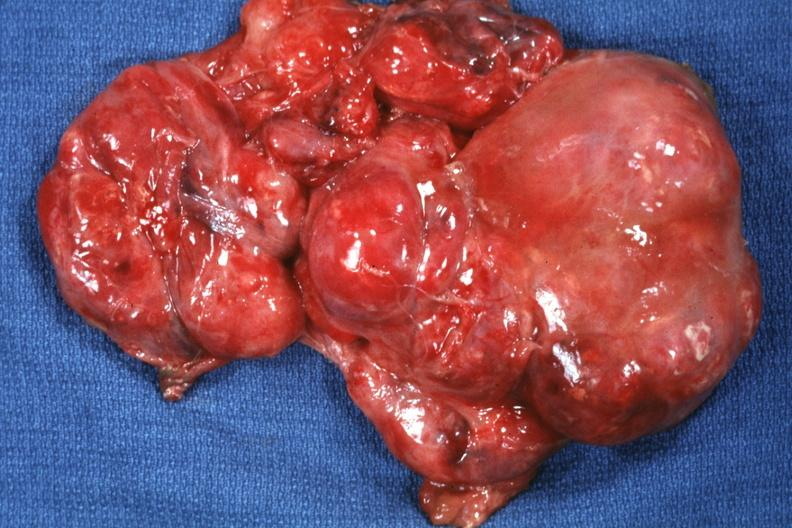does abdomen show excised tumor?
Answer the question using a single word or phrase. No 